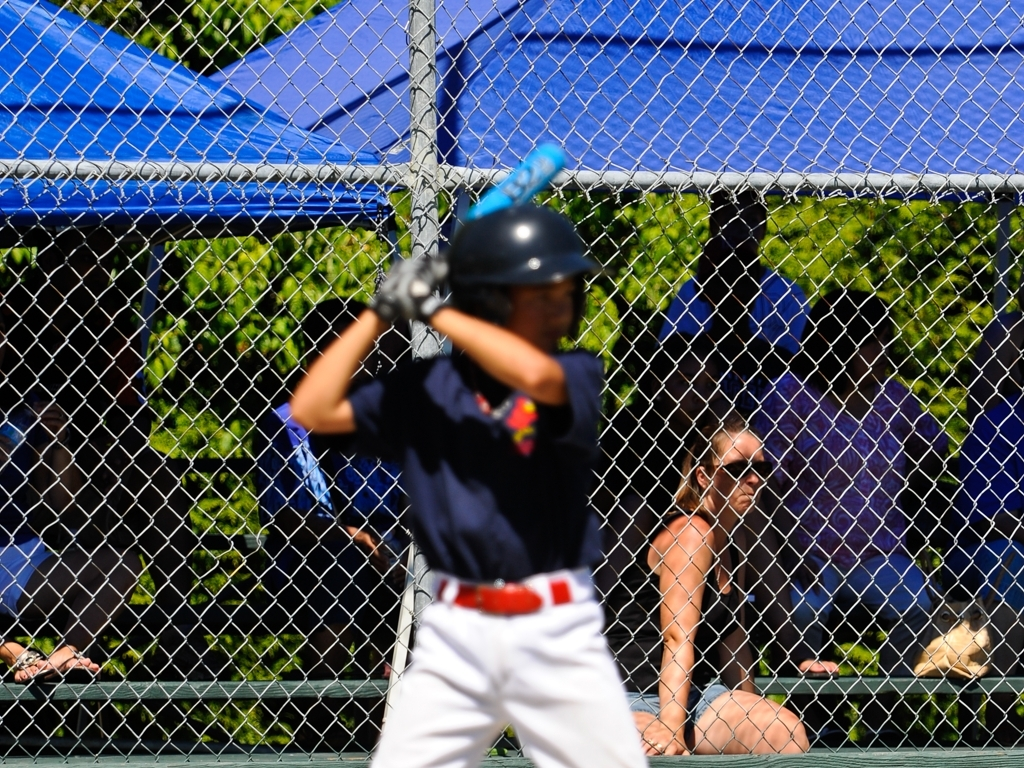How would you describe the image quality?
A. Excellent
B. Poor
C. Average The image quality can be described as poor. This assessment is due to the noticeable blur affecting the main subject of the photo, which is a player at bat in a baseball game. The player's movement is not captured with clarity, which often indicates a lower shutter speed that wasn't sufficient to freeze the action of the sports event, leading to a lack of sharpness in the details. 